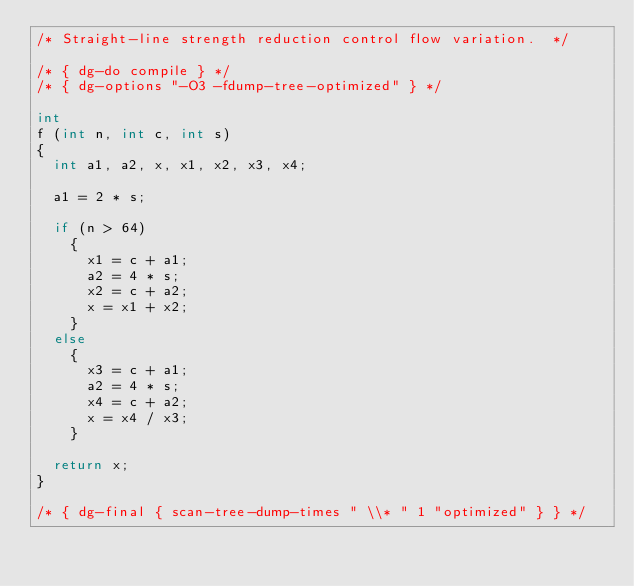Convert code to text. <code><loc_0><loc_0><loc_500><loc_500><_C_>/* Straight-line strength reduction control flow variation.  */

/* { dg-do compile } */
/* { dg-options "-O3 -fdump-tree-optimized" } */

int
f (int n, int c, int s)
{
  int a1, a2, x, x1, x2, x3, x4;

  a1 = 2 * s;

  if (n > 64)
    {
      x1 = c + a1;
      a2 = 4 * s;
      x2 = c + a2;
      x = x1 + x2;
    }
  else
    {
      x3 = c + a1;
      a2 = 4 * s;
      x4 = c + a2;
      x = x4 / x3;
    }

  return x;
}

/* { dg-final { scan-tree-dump-times " \\* " 1 "optimized" } } */
</code> 